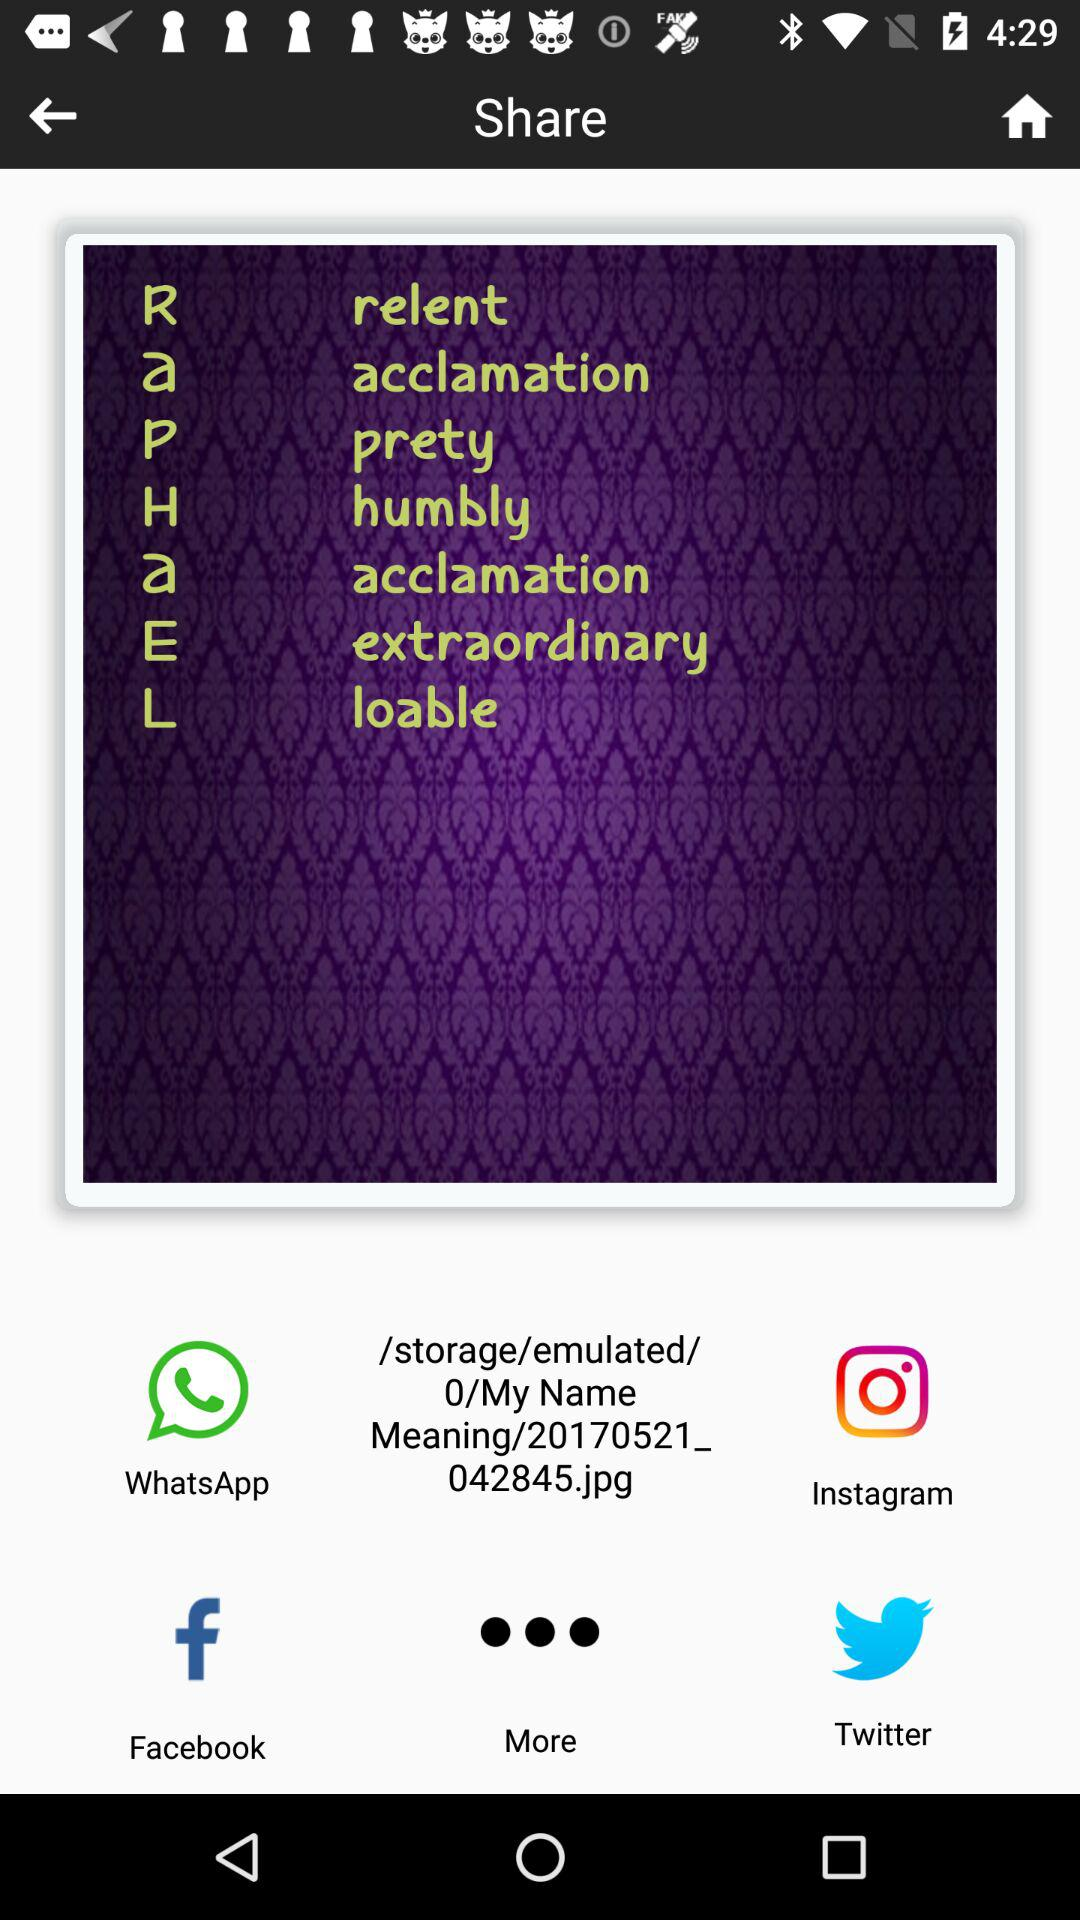Which word does R stand for? R stands for "relent". 